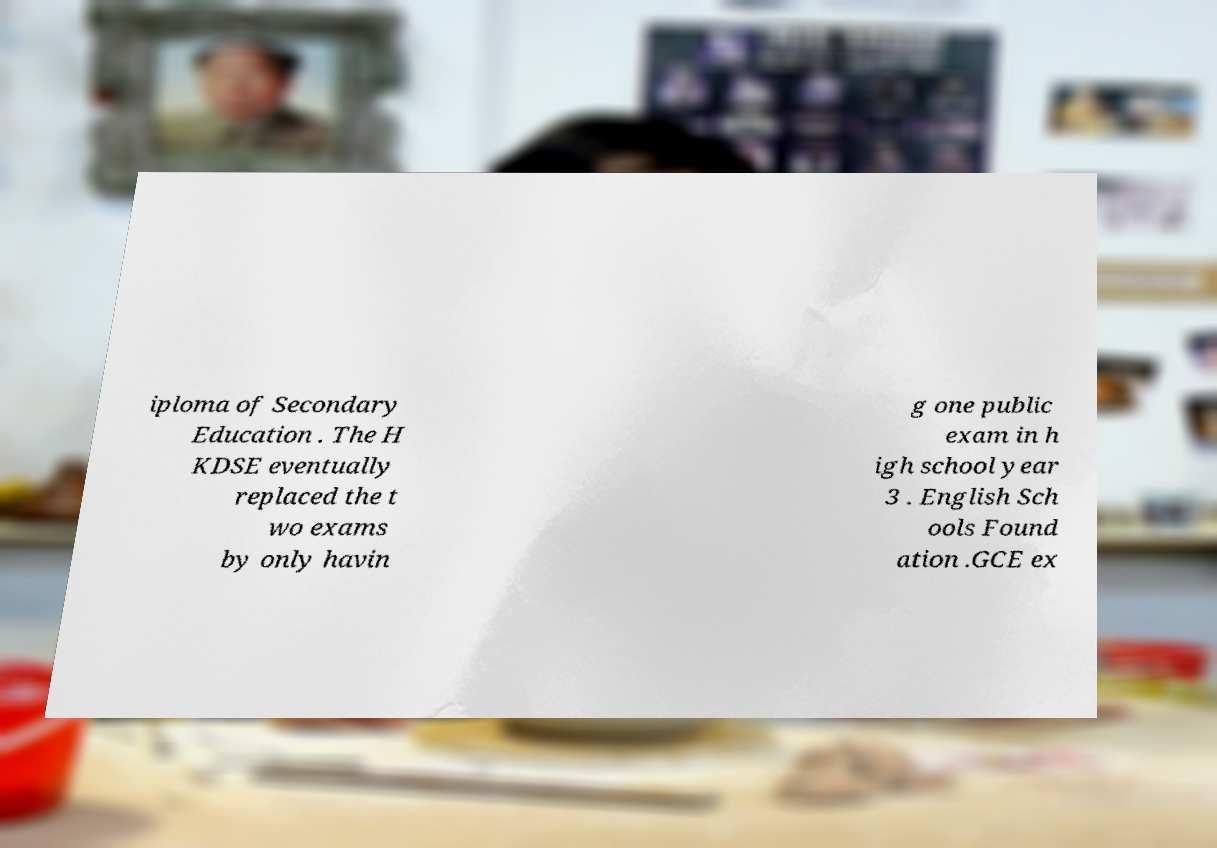I need the written content from this picture converted into text. Can you do that? iploma of Secondary Education . The H KDSE eventually replaced the t wo exams by only havin g one public exam in h igh school year 3 . English Sch ools Found ation .GCE ex 